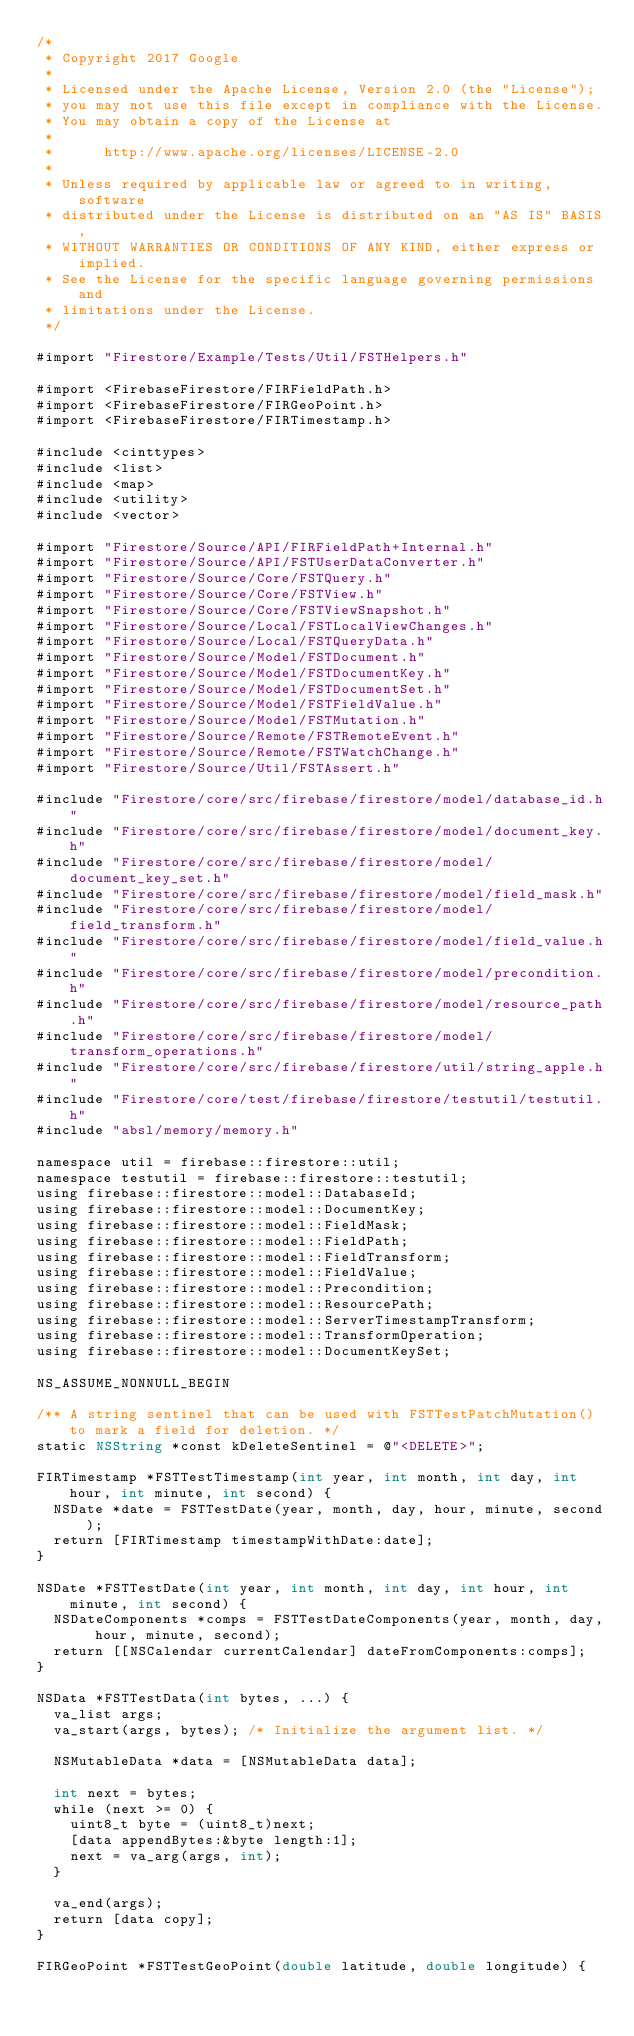Convert code to text. <code><loc_0><loc_0><loc_500><loc_500><_ObjectiveC_>/*
 * Copyright 2017 Google
 *
 * Licensed under the Apache License, Version 2.0 (the "License");
 * you may not use this file except in compliance with the License.
 * You may obtain a copy of the License at
 *
 *      http://www.apache.org/licenses/LICENSE-2.0
 *
 * Unless required by applicable law or agreed to in writing, software
 * distributed under the License is distributed on an "AS IS" BASIS,
 * WITHOUT WARRANTIES OR CONDITIONS OF ANY KIND, either express or implied.
 * See the License for the specific language governing permissions and
 * limitations under the License.
 */

#import "Firestore/Example/Tests/Util/FSTHelpers.h"

#import <FirebaseFirestore/FIRFieldPath.h>
#import <FirebaseFirestore/FIRGeoPoint.h>
#import <FirebaseFirestore/FIRTimestamp.h>

#include <cinttypes>
#include <list>
#include <map>
#include <utility>
#include <vector>

#import "Firestore/Source/API/FIRFieldPath+Internal.h"
#import "Firestore/Source/API/FSTUserDataConverter.h"
#import "Firestore/Source/Core/FSTQuery.h"
#import "Firestore/Source/Core/FSTView.h"
#import "Firestore/Source/Core/FSTViewSnapshot.h"
#import "Firestore/Source/Local/FSTLocalViewChanges.h"
#import "Firestore/Source/Local/FSTQueryData.h"
#import "Firestore/Source/Model/FSTDocument.h"
#import "Firestore/Source/Model/FSTDocumentKey.h"
#import "Firestore/Source/Model/FSTDocumentSet.h"
#import "Firestore/Source/Model/FSTFieldValue.h"
#import "Firestore/Source/Model/FSTMutation.h"
#import "Firestore/Source/Remote/FSTRemoteEvent.h"
#import "Firestore/Source/Remote/FSTWatchChange.h"
#import "Firestore/Source/Util/FSTAssert.h"

#include "Firestore/core/src/firebase/firestore/model/database_id.h"
#include "Firestore/core/src/firebase/firestore/model/document_key.h"
#include "Firestore/core/src/firebase/firestore/model/document_key_set.h"
#include "Firestore/core/src/firebase/firestore/model/field_mask.h"
#include "Firestore/core/src/firebase/firestore/model/field_transform.h"
#include "Firestore/core/src/firebase/firestore/model/field_value.h"
#include "Firestore/core/src/firebase/firestore/model/precondition.h"
#include "Firestore/core/src/firebase/firestore/model/resource_path.h"
#include "Firestore/core/src/firebase/firestore/model/transform_operations.h"
#include "Firestore/core/src/firebase/firestore/util/string_apple.h"
#include "Firestore/core/test/firebase/firestore/testutil/testutil.h"
#include "absl/memory/memory.h"

namespace util = firebase::firestore::util;
namespace testutil = firebase::firestore::testutil;
using firebase::firestore::model::DatabaseId;
using firebase::firestore::model::DocumentKey;
using firebase::firestore::model::FieldMask;
using firebase::firestore::model::FieldPath;
using firebase::firestore::model::FieldTransform;
using firebase::firestore::model::FieldValue;
using firebase::firestore::model::Precondition;
using firebase::firestore::model::ResourcePath;
using firebase::firestore::model::ServerTimestampTransform;
using firebase::firestore::model::TransformOperation;
using firebase::firestore::model::DocumentKeySet;

NS_ASSUME_NONNULL_BEGIN

/** A string sentinel that can be used with FSTTestPatchMutation() to mark a field for deletion. */
static NSString *const kDeleteSentinel = @"<DELETE>";

FIRTimestamp *FSTTestTimestamp(int year, int month, int day, int hour, int minute, int second) {
  NSDate *date = FSTTestDate(year, month, day, hour, minute, second);
  return [FIRTimestamp timestampWithDate:date];
}

NSDate *FSTTestDate(int year, int month, int day, int hour, int minute, int second) {
  NSDateComponents *comps = FSTTestDateComponents(year, month, day, hour, minute, second);
  return [[NSCalendar currentCalendar] dateFromComponents:comps];
}

NSData *FSTTestData(int bytes, ...) {
  va_list args;
  va_start(args, bytes); /* Initialize the argument list. */

  NSMutableData *data = [NSMutableData data];

  int next = bytes;
  while (next >= 0) {
    uint8_t byte = (uint8_t)next;
    [data appendBytes:&byte length:1];
    next = va_arg(args, int);
  }

  va_end(args);
  return [data copy];
}

FIRGeoPoint *FSTTestGeoPoint(double latitude, double longitude) {</code> 